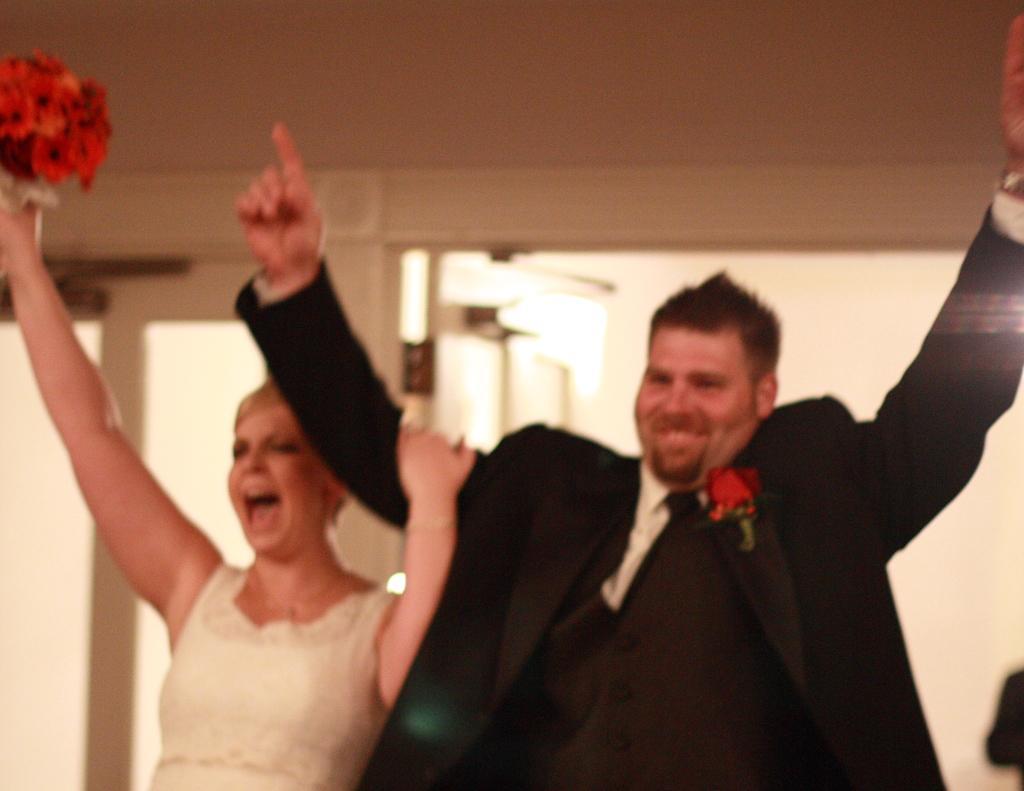Please provide a concise description of this image. In the image we can see there are people standing and the woman is holding a bouquet in her hand. The man is wearing a suit. 